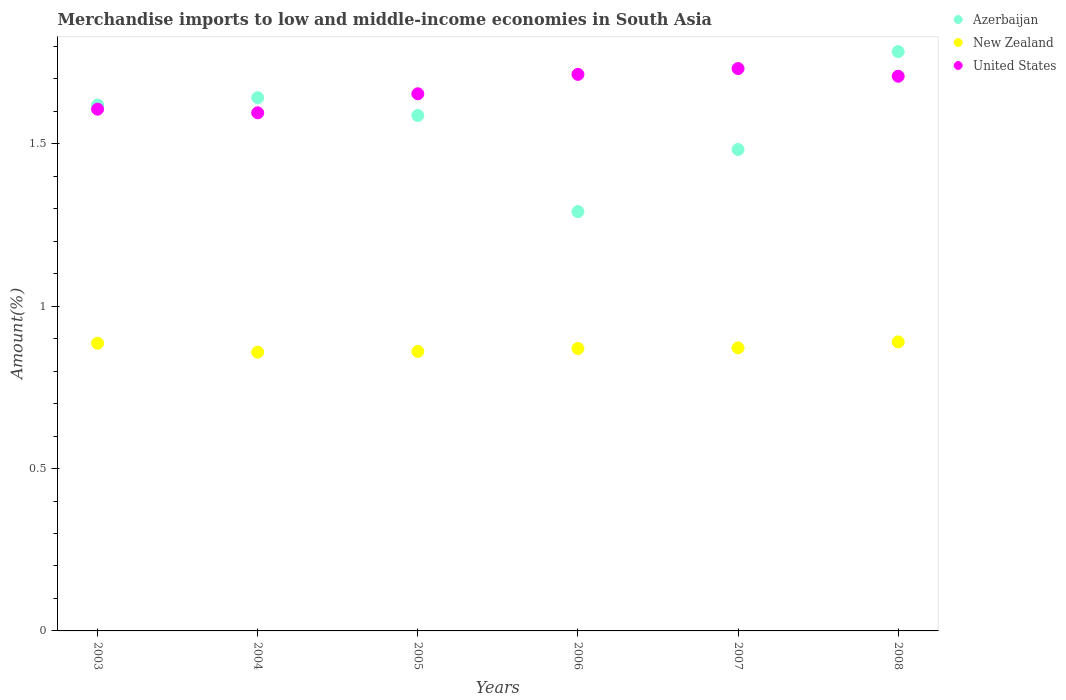What is the percentage of amount earned from merchandise imports in New Zealand in 2006?
Offer a terse response. 0.87. Across all years, what is the maximum percentage of amount earned from merchandise imports in United States?
Provide a short and direct response. 1.73. Across all years, what is the minimum percentage of amount earned from merchandise imports in Azerbaijan?
Give a very brief answer. 1.29. What is the total percentage of amount earned from merchandise imports in United States in the graph?
Offer a terse response. 10.01. What is the difference between the percentage of amount earned from merchandise imports in Azerbaijan in 2004 and that in 2008?
Your response must be concise. -0.14. What is the difference between the percentage of amount earned from merchandise imports in United States in 2006 and the percentage of amount earned from merchandise imports in New Zealand in 2003?
Your answer should be compact. 0.83. What is the average percentage of amount earned from merchandise imports in New Zealand per year?
Make the answer very short. 0.87. In the year 2007, what is the difference between the percentage of amount earned from merchandise imports in New Zealand and percentage of amount earned from merchandise imports in United States?
Give a very brief answer. -0.86. In how many years, is the percentage of amount earned from merchandise imports in United States greater than 0.8 %?
Your answer should be very brief. 6. What is the ratio of the percentage of amount earned from merchandise imports in United States in 2003 to that in 2005?
Your response must be concise. 0.97. What is the difference between the highest and the second highest percentage of amount earned from merchandise imports in Azerbaijan?
Provide a short and direct response. 0.14. What is the difference between the highest and the lowest percentage of amount earned from merchandise imports in United States?
Offer a terse response. 0.14. Is the percentage of amount earned from merchandise imports in New Zealand strictly greater than the percentage of amount earned from merchandise imports in Azerbaijan over the years?
Keep it short and to the point. No. What is the difference between two consecutive major ticks on the Y-axis?
Give a very brief answer. 0.5. Does the graph contain any zero values?
Ensure brevity in your answer.  No. How are the legend labels stacked?
Provide a short and direct response. Vertical. What is the title of the graph?
Ensure brevity in your answer.  Merchandise imports to low and middle-income economies in South Asia. Does "East Asia (all income levels)" appear as one of the legend labels in the graph?
Make the answer very short. No. What is the label or title of the X-axis?
Ensure brevity in your answer.  Years. What is the label or title of the Y-axis?
Your answer should be very brief. Amount(%). What is the Amount(%) in Azerbaijan in 2003?
Your response must be concise. 1.62. What is the Amount(%) of New Zealand in 2003?
Give a very brief answer. 0.89. What is the Amount(%) of United States in 2003?
Offer a very short reply. 1.61. What is the Amount(%) of Azerbaijan in 2004?
Give a very brief answer. 1.64. What is the Amount(%) of New Zealand in 2004?
Provide a succinct answer. 0.86. What is the Amount(%) of United States in 2004?
Your answer should be compact. 1.6. What is the Amount(%) in Azerbaijan in 2005?
Offer a very short reply. 1.59. What is the Amount(%) of New Zealand in 2005?
Your response must be concise. 0.86. What is the Amount(%) of United States in 2005?
Offer a very short reply. 1.65. What is the Amount(%) of Azerbaijan in 2006?
Your response must be concise. 1.29. What is the Amount(%) of New Zealand in 2006?
Offer a terse response. 0.87. What is the Amount(%) of United States in 2006?
Your answer should be compact. 1.71. What is the Amount(%) of Azerbaijan in 2007?
Offer a very short reply. 1.48. What is the Amount(%) in New Zealand in 2007?
Provide a short and direct response. 0.87. What is the Amount(%) of United States in 2007?
Your response must be concise. 1.73. What is the Amount(%) of Azerbaijan in 2008?
Your answer should be very brief. 1.78. What is the Amount(%) in New Zealand in 2008?
Give a very brief answer. 0.89. What is the Amount(%) in United States in 2008?
Offer a very short reply. 1.71. Across all years, what is the maximum Amount(%) of Azerbaijan?
Offer a terse response. 1.78. Across all years, what is the maximum Amount(%) of New Zealand?
Give a very brief answer. 0.89. Across all years, what is the maximum Amount(%) of United States?
Keep it short and to the point. 1.73. Across all years, what is the minimum Amount(%) of Azerbaijan?
Make the answer very short. 1.29. Across all years, what is the minimum Amount(%) in New Zealand?
Ensure brevity in your answer.  0.86. Across all years, what is the minimum Amount(%) of United States?
Provide a short and direct response. 1.6. What is the total Amount(%) of Azerbaijan in the graph?
Provide a succinct answer. 9.41. What is the total Amount(%) of New Zealand in the graph?
Ensure brevity in your answer.  5.24. What is the total Amount(%) of United States in the graph?
Ensure brevity in your answer.  10.01. What is the difference between the Amount(%) in Azerbaijan in 2003 and that in 2004?
Offer a terse response. -0.02. What is the difference between the Amount(%) of New Zealand in 2003 and that in 2004?
Your response must be concise. 0.03. What is the difference between the Amount(%) in United States in 2003 and that in 2004?
Provide a short and direct response. 0.01. What is the difference between the Amount(%) of Azerbaijan in 2003 and that in 2005?
Provide a short and direct response. 0.03. What is the difference between the Amount(%) of New Zealand in 2003 and that in 2005?
Your answer should be very brief. 0.03. What is the difference between the Amount(%) in United States in 2003 and that in 2005?
Ensure brevity in your answer.  -0.05. What is the difference between the Amount(%) of Azerbaijan in 2003 and that in 2006?
Make the answer very short. 0.33. What is the difference between the Amount(%) in New Zealand in 2003 and that in 2006?
Ensure brevity in your answer.  0.02. What is the difference between the Amount(%) of United States in 2003 and that in 2006?
Provide a succinct answer. -0.11. What is the difference between the Amount(%) in Azerbaijan in 2003 and that in 2007?
Your answer should be very brief. 0.14. What is the difference between the Amount(%) of New Zealand in 2003 and that in 2007?
Your response must be concise. 0.01. What is the difference between the Amount(%) of United States in 2003 and that in 2007?
Your answer should be very brief. -0.12. What is the difference between the Amount(%) of Azerbaijan in 2003 and that in 2008?
Your answer should be compact. -0.16. What is the difference between the Amount(%) of New Zealand in 2003 and that in 2008?
Provide a succinct answer. -0. What is the difference between the Amount(%) of United States in 2003 and that in 2008?
Your response must be concise. -0.1. What is the difference between the Amount(%) of Azerbaijan in 2004 and that in 2005?
Provide a short and direct response. 0.05. What is the difference between the Amount(%) of New Zealand in 2004 and that in 2005?
Offer a very short reply. -0. What is the difference between the Amount(%) in United States in 2004 and that in 2005?
Give a very brief answer. -0.06. What is the difference between the Amount(%) of Azerbaijan in 2004 and that in 2006?
Give a very brief answer. 0.35. What is the difference between the Amount(%) in New Zealand in 2004 and that in 2006?
Your answer should be very brief. -0.01. What is the difference between the Amount(%) of United States in 2004 and that in 2006?
Keep it short and to the point. -0.12. What is the difference between the Amount(%) of Azerbaijan in 2004 and that in 2007?
Your answer should be compact. 0.16. What is the difference between the Amount(%) of New Zealand in 2004 and that in 2007?
Keep it short and to the point. -0.01. What is the difference between the Amount(%) of United States in 2004 and that in 2007?
Give a very brief answer. -0.14. What is the difference between the Amount(%) of Azerbaijan in 2004 and that in 2008?
Keep it short and to the point. -0.14. What is the difference between the Amount(%) in New Zealand in 2004 and that in 2008?
Provide a short and direct response. -0.03. What is the difference between the Amount(%) of United States in 2004 and that in 2008?
Ensure brevity in your answer.  -0.11. What is the difference between the Amount(%) in Azerbaijan in 2005 and that in 2006?
Give a very brief answer. 0.3. What is the difference between the Amount(%) of New Zealand in 2005 and that in 2006?
Offer a terse response. -0.01. What is the difference between the Amount(%) of United States in 2005 and that in 2006?
Provide a succinct answer. -0.06. What is the difference between the Amount(%) in Azerbaijan in 2005 and that in 2007?
Your answer should be very brief. 0.1. What is the difference between the Amount(%) in New Zealand in 2005 and that in 2007?
Provide a short and direct response. -0.01. What is the difference between the Amount(%) in United States in 2005 and that in 2007?
Offer a terse response. -0.08. What is the difference between the Amount(%) of Azerbaijan in 2005 and that in 2008?
Offer a very short reply. -0.2. What is the difference between the Amount(%) in New Zealand in 2005 and that in 2008?
Ensure brevity in your answer.  -0.03. What is the difference between the Amount(%) of United States in 2005 and that in 2008?
Provide a succinct answer. -0.05. What is the difference between the Amount(%) in Azerbaijan in 2006 and that in 2007?
Ensure brevity in your answer.  -0.19. What is the difference between the Amount(%) of New Zealand in 2006 and that in 2007?
Provide a short and direct response. -0. What is the difference between the Amount(%) of United States in 2006 and that in 2007?
Ensure brevity in your answer.  -0.02. What is the difference between the Amount(%) in Azerbaijan in 2006 and that in 2008?
Provide a short and direct response. -0.49. What is the difference between the Amount(%) of New Zealand in 2006 and that in 2008?
Provide a succinct answer. -0.02. What is the difference between the Amount(%) in United States in 2006 and that in 2008?
Offer a very short reply. 0.01. What is the difference between the Amount(%) in Azerbaijan in 2007 and that in 2008?
Make the answer very short. -0.3. What is the difference between the Amount(%) in New Zealand in 2007 and that in 2008?
Offer a very short reply. -0.02. What is the difference between the Amount(%) in United States in 2007 and that in 2008?
Offer a very short reply. 0.02. What is the difference between the Amount(%) in Azerbaijan in 2003 and the Amount(%) in New Zealand in 2004?
Your answer should be very brief. 0.76. What is the difference between the Amount(%) in Azerbaijan in 2003 and the Amount(%) in United States in 2004?
Offer a terse response. 0.02. What is the difference between the Amount(%) of New Zealand in 2003 and the Amount(%) of United States in 2004?
Keep it short and to the point. -0.71. What is the difference between the Amount(%) in Azerbaijan in 2003 and the Amount(%) in New Zealand in 2005?
Your answer should be very brief. 0.76. What is the difference between the Amount(%) of Azerbaijan in 2003 and the Amount(%) of United States in 2005?
Give a very brief answer. -0.03. What is the difference between the Amount(%) of New Zealand in 2003 and the Amount(%) of United States in 2005?
Provide a short and direct response. -0.77. What is the difference between the Amount(%) in Azerbaijan in 2003 and the Amount(%) in New Zealand in 2006?
Give a very brief answer. 0.75. What is the difference between the Amount(%) of Azerbaijan in 2003 and the Amount(%) of United States in 2006?
Offer a terse response. -0.09. What is the difference between the Amount(%) in New Zealand in 2003 and the Amount(%) in United States in 2006?
Offer a terse response. -0.83. What is the difference between the Amount(%) of Azerbaijan in 2003 and the Amount(%) of New Zealand in 2007?
Offer a very short reply. 0.75. What is the difference between the Amount(%) of Azerbaijan in 2003 and the Amount(%) of United States in 2007?
Provide a short and direct response. -0.11. What is the difference between the Amount(%) of New Zealand in 2003 and the Amount(%) of United States in 2007?
Your answer should be compact. -0.85. What is the difference between the Amount(%) of Azerbaijan in 2003 and the Amount(%) of New Zealand in 2008?
Offer a terse response. 0.73. What is the difference between the Amount(%) of Azerbaijan in 2003 and the Amount(%) of United States in 2008?
Provide a succinct answer. -0.09. What is the difference between the Amount(%) in New Zealand in 2003 and the Amount(%) in United States in 2008?
Offer a very short reply. -0.82. What is the difference between the Amount(%) in Azerbaijan in 2004 and the Amount(%) in New Zealand in 2005?
Your answer should be compact. 0.78. What is the difference between the Amount(%) of Azerbaijan in 2004 and the Amount(%) of United States in 2005?
Give a very brief answer. -0.01. What is the difference between the Amount(%) of New Zealand in 2004 and the Amount(%) of United States in 2005?
Keep it short and to the point. -0.8. What is the difference between the Amount(%) of Azerbaijan in 2004 and the Amount(%) of New Zealand in 2006?
Keep it short and to the point. 0.77. What is the difference between the Amount(%) in Azerbaijan in 2004 and the Amount(%) in United States in 2006?
Provide a short and direct response. -0.07. What is the difference between the Amount(%) in New Zealand in 2004 and the Amount(%) in United States in 2006?
Your answer should be very brief. -0.86. What is the difference between the Amount(%) in Azerbaijan in 2004 and the Amount(%) in New Zealand in 2007?
Provide a short and direct response. 0.77. What is the difference between the Amount(%) of Azerbaijan in 2004 and the Amount(%) of United States in 2007?
Provide a succinct answer. -0.09. What is the difference between the Amount(%) of New Zealand in 2004 and the Amount(%) of United States in 2007?
Keep it short and to the point. -0.87. What is the difference between the Amount(%) in Azerbaijan in 2004 and the Amount(%) in New Zealand in 2008?
Your answer should be compact. 0.75. What is the difference between the Amount(%) in Azerbaijan in 2004 and the Amount(%) in United States in 2008?
Your answer should be very brief. -0.07. What is the difference between the Amount(%) in New Zealand in 2004 and the Amount(%) in United States in 2008?
Offer a terse response. -0.85. What is the difference between the Amount(%) in Azerbaijan in 2005 and the Amount(%) in New Zealand in 2006?
Offer a very short reply. 0.72. What is the difference between the Amount(%) in Azerbaijan in 2005 and the Amount(%) in United States in 2006?
Offer a very short reply. -0.13. What is the difference between the Amount(%) of New Zealand in 2005 and the Amount(%) of United States in 2006?
Offer a terse response. -0.85. What is the difference between the Amount(%) in Azerbaijan in 2005 and the Amount(%) in New Zealand in 2007?
Give a very brief answer. 0.72. What is the difference between the Amount(%) of Azerbaijan in 2005 and the Amount(%) of United States in 2007?
Keep it short and to the point. -0.14. What is the difference between the Amount(%) in New Zealand in 2005 and the Amount(%) in United States in 2007?
Ensure brevity in your answer.  -0.87. What is the difference between the Amount(%) in Azerbaijan in 2005 and the Amount(%) in New Zealand in 2008?
Your response must be concise. 0.7. What is the difference between the Amount(%) in Azerbaijan in 2005 and the Amount(%) in United States in 2008?
Ensure brevity in your answer.  -0.12. What is the difference between the Amount(%) in New Zealand in 2005 and the Amount(%) in United States in 2008?
Your answer should be very brief. -0.85. What is the difference between the Amount(%) of Azerbaijan in 2006 and the Amount(%) of New Zealand in 2007?
Your response must be concise. 0.42. What is the difference between the Amount(%) of Azerbaijan in 2006 and the Amount(%) of United States in 2007?
Your response must be concise. -0.44. What is the difference between the Amount(%) in New Zealand in 2006 and the Amount(%) in United States in 2007?
Provide a succinct answer. -0.86. What is the difference between the Amount(%) in Azerbaijan in 2006 and the Amount(%) in New Zealand in 2008?
Your response must be concise. 0.4. What is the difference between the Amount(%) in Azerbaijan in 2006 and the Amount(%) in United States in 2008?
Your answer should be very brief. -0.42. What is the difference between the Amount(%) of New Zealand in 2006 and the Amount(%) of United States in 2008?
Provide a short and direct response. -0.84. What is the difference between the Amount(%) of Azerbaijan in 2007 and the Amount(%) of New Zealand in 2008?
Make the answer very short. 0.59. What is the difference between the Amount(%) in Azerbaijan in 2007 and the Amount(%) in United States in 2008?
Make the answer very short. -0.23. What is the difference between the Amount(%) of New Zealand in 2007 and the Amount(%) of United States in 2008?
Offer a very short reply. -0.84. What is the average Amount(%) in Azerbaijan per year?
Offer a terse response. 1.57. What is the average Amount(%) of New Zealand per year?
Your answer should be very brief. 0.87. What is the average Amount(%) in United States per year?
Ensure brevity in your answer.  1.67. In the year 2003, what is the difference between the Amount(%) of Azerbaijan and Amount(%) of New Zealand?
Offer a very short reply. 0.73. In the year 2003, what is the difference between the Amount(%) in Azerbaijan and Amount(%) in United States?
Your answer should be very brief. 0.01. In the year 2003, what is the difference between the Amount(%) of New Zealand and Amount(%) of United States?
Give a very brief answer. -0.72. In the year 2004, what is the difference between the Amount(%) in Azerbaijan and Amount(%) in New Zealand?
Make the answer very short. 0.78. In the year 2004, what is the difference between the Amount(%) of Azerbaijan and Amount(%) of United States?
Keep it short and to the point. 0.05. In the year 2004, what is the difference between the Amount(%) in New Zealand and Amount(%) in United States?
Offer a very short reply. -0.74. In the year 2005, what is the difference between the Amount(%) of Azerbaijan and Amount(%) of New Zealand?
Your answer should be compact. 0.73. In the year 2005, what is the difference between the Amount(%) in Azerbaijan and Amount(%) in United States?
Your answer should be compact. -0.07. In the year 2005, what is the difference between the Amount(%) in New Zealand and Amount(%) in United States?
Your answer should be compact. -0.79. In the year 2006, what is the difference between the Amount(%) in Azerbaijan and Amount(%) in New Zealand?
Offer a very short reply. 0.42. In the year 2006, what is the difference between the Amount(%) of Azerbaijan and Amount(%) of United States?
Provide a short and direct response. -0.42. In the year 2006, what is the difference between the Amount(%) of New Zealand and Amount(%) of United States?
Your answer should be compact. -0.84. In the year 2007, what is the difference between the Amount(%) in Azerbaijan and Amount(%) in New Zealand?
Give a very brief answer. 0.61. In the year 2007, what is the difference between the Amount(%) of Azerbaijan and Amount(%) of United States?
Your answer should be very brief. -0.25. In the year 2007, what is the difference between the Amount(%) in New Zealand and Amount(%) in United States?
Your response must be concise. -0.86. In the year 2008, what is the difference between the Amount(%) of Azerbaijan and Amount(%) of New Zealand?
Give a very brief answer. 0.89. In the year 2008, what is the difference between the Amount(%) in Azerbaijan and Amount(%) in United States?
Your response must be concise. 0.08. In the year 2008, what is the difference between the Amount(%) in New Zealand and Amount(%) in United States?
Your answer should be compact. -0.82. What is the ratio of the Amount(%) of Azerbaijan in 2003 to that in 2004?
Offer a very short reply. 0.99. What is the ratio of the Amount(%) in New Zealand in 2003 to that in 2004?
Ensure brevity in your answer.  1.03. What is the ratio of the Amount(%) of Azerbaijan in 2003 to that in 2005?
Offer a terse response. 1.02. What is the ratio of the Amount(%) in New Zealand in 2003 to that in 2005?
Provide a succinct answer. 1.03. What is the ratio of the Amount(%) of United States in 2003 to that in 2005?
Keep it short and to the point. 0.97. What is the ratio of the Amount(%) of Azerbaijan in 2003 to that in 2006?
Your response must be concise. 1.25. What is the ratio of the Amount(%) in New Zealand in 2003 to that in 2006?
Keep it short and to the point. 1.02. What is the ratio of the Amount(%) in Azerbaijan in 2003 to that in 2007?
Offer a terse response. 1.09. What is the ratio of the Amount(%) in New Zealand in 2003 to that in 2007?
Your answer should be compact. 1.02. What is the ratio of the Amount(%) in United States in 2003 to that in 2007?
Provide a short and direct response. 0.93. What is the ratio of the Amount(%) in Azerbaijan in 2003 to that in 2008?
Your answer should be very brief. 0.91. What is the ratio of the Amount(%) in United States in 2003 to that in 2008?
Keep it short and to the point. 0.94. What is the ratio of the Amount(%) in Azerbaijan in 2004 to that in 2005?
Your response must be concise. 1.03. What is the ratio of the Amount(%) in New Zealand in 2004 to that in 2005?
Your answer should be very brief. 1. What is the ratio of the Amount(%) in United States in 2004 to that in 2005?
Your answer should be very brief. 0.96. What is the ratio of the Amount(%) of Azerbaijan in 2004 to that in 2006?
Provide a short and direct response. 1.27. What is the ratio of the Amount(%) of New Zealand in 2004 to that in 2006?
Give a very brief answer. 0.99. What is the ratio of the Amount(%) in United States in 2004 to that in 2006?
Provide a short and direct response. 0.93. What is the ratio of the Amount(%) of Azerbaijan in 2004 to that in 2007?
Your answer should be very brief. 1.11. What is the ratio of the Amount(%) of New Zealand in 2004 to that in 2007?
Ensure brevity in your answer.  0.98. What is the ratio of the Amount(%) of United States in 2004 to that in 2007?
Your answer should be compact. 0.92. What is the ratio of the Amount(%) of Azerbaijan in 2004 to that in 2008?
Ensure brevity in your answer.  0.92. What is the ratio of the Amount(%) in New Zealand in 2004 to that in 2008?
Give a very brief answer. 0.96. What is the ratio of the Amount(%) in United States in 2004 to that in 2008?
Keep it short and to the point. 0.93. What is the ratio of the Amount(%) in Azerbaijan in 2005 to that in 2006?
Provide a succinct answer. 1.23. What is the ratio of the Amount(%) of New Zealand in 2005 to that in 2006?
Offer a very short reply. 0.99. What is the ratio of the Amount(%) in United States in 2005 to that in 2006?
Your response must be concise. 0.97. What is the ratio of the Amount(%) of Azerbaijan in 2005 to that in 2007?
Offer a very short reply. 1.07. What is the ratio of the Amount(%) in New Zealand in 2005 to that in 2007?
Make the answer very short. 0.99. What is the ratio of the Amount(%) of United States in 2005 to that in 2007?
Make the answer very short. 0.96. What is the ratio of the Amount(%) in Azerbaijan in 2005 to that in 2008?
Make the answer very short. 0.89. What is the ratio of the Amount(%) in New Zealand in 2005 to that in 2008?
Your answer should be compact. 0.97. What is the ratio of the Amount(%) of United States in 2005 to that in 2008?
Provide a short and direct response. 0.97. What is the ratio of the Amount(%) in Azerbaijan in 2006 to that in 2007?
Offer a terse response. 0.87. What is the ratio of the Amount(%) of New Zealand in 2006 to that in 2007?
Keep it short and to the point. 1. What is the ratio of the Amount(%) of Azerbaijan in 2006 to that in 2008?
Your answer should be very brief. 0.72. What is the ratio of the Amount(%) of New Zealand in 2006 to that in 2008?
Your response must be concise. 0.98. What is the ratio of the Amount(%) in United States in 2006 to that in 2008?
Offer a very short reply. 1. What is the ratio of the Amount(%) of Azerbaijan in 2007 to that in 2008?
Give a very brief answer. 0.83. What is the ratio of the Amount(%) of New Zealand in 2007 to that in 2008?
Offer a very short reply. 0.98. What is the ratio of the Amount(%) in United States in 2007 to that in 2008?
Your answer should be very brief. 1.01. What is the difference between the highest and the second highest Amount(%) in Azerbaijan?
Make the answer very short. 0.14. What is the difference between the highest and the second highest Amount(%) of New Zealand?
Make the answer very short. 0. What is the difference between the highest and the second highest Amount(%) in United States?
Ensure brevity in your answer.  0.02. What is the difference between the highest and the lowest Amount(%) in Azerbaijan?
Keep it short and to the point. 0.49. What is the difference between the highest and the lowest Amount(%) of New Zealand?
Your answer should be compact. 0.03. What is the difference between the highest and the lowest Amount(%) of United States?
Give a very brief answer. 0.14. 